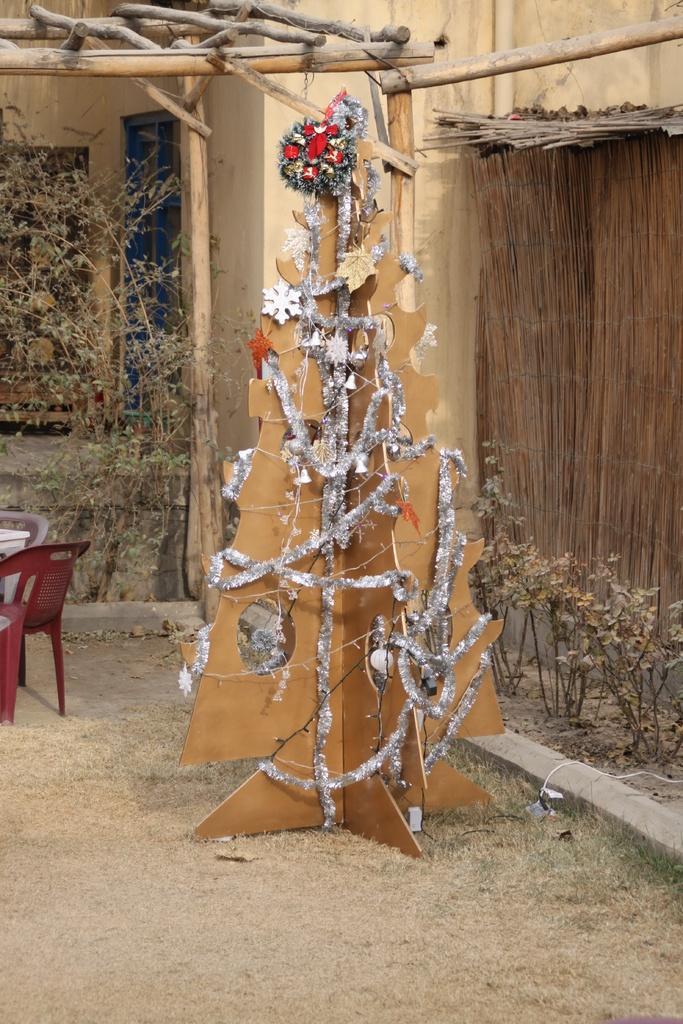Please provide a concise description of this image. In this image there is a christmas tree which is made up of cardboard box, beside that there are small plants,beside the plant there is wall, in the background there is a house, in front of the house there is a plant and chairs. 